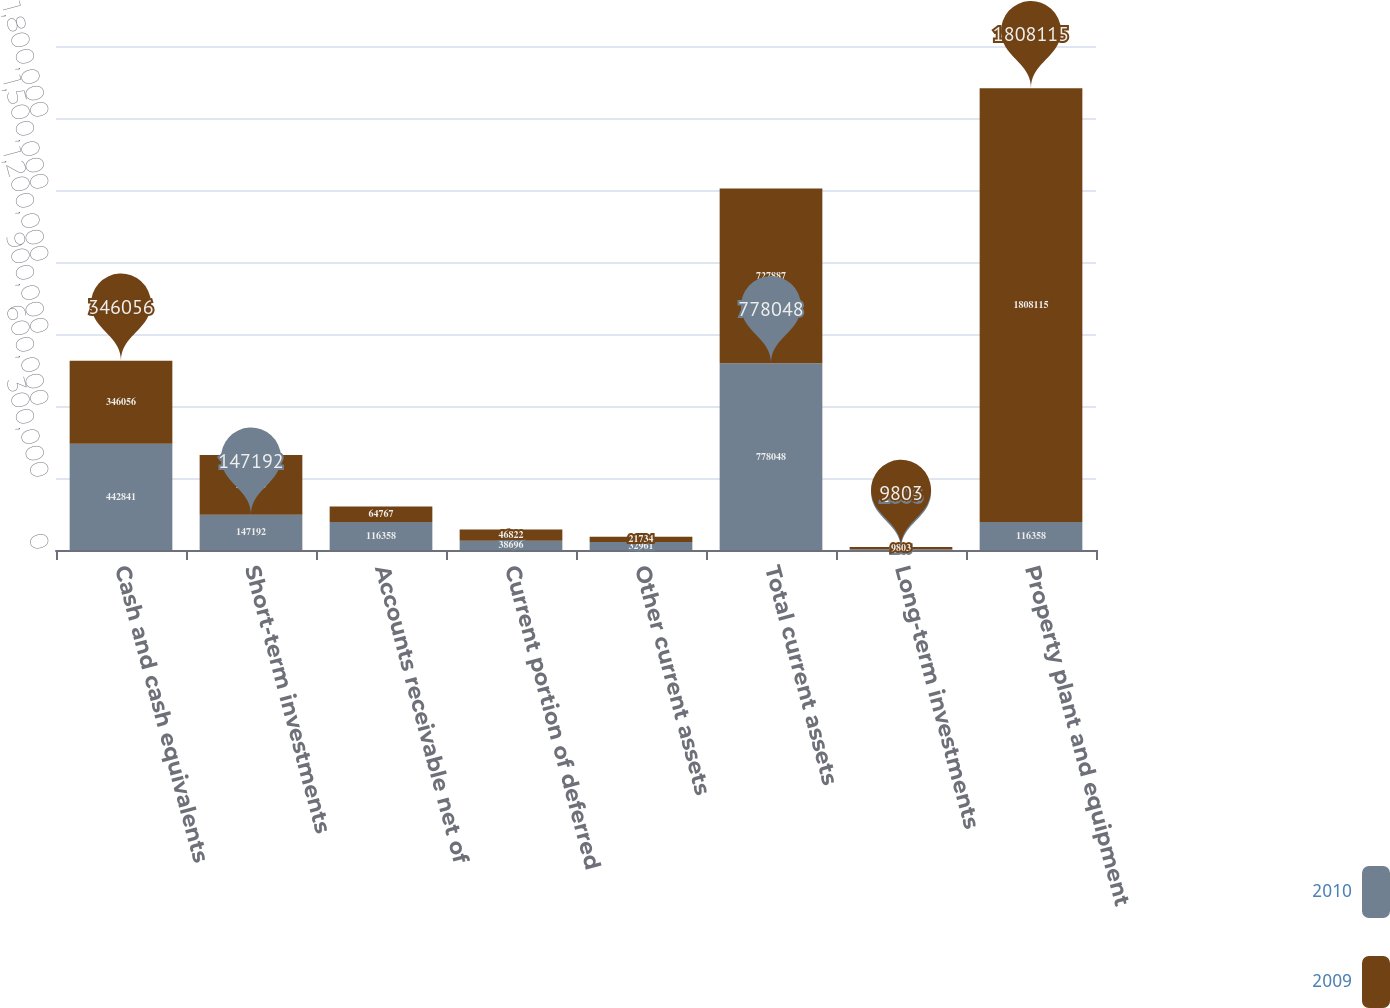Convert chart to OTSL. <chart><loc_0><loc_0><loc_500><loc_500><stacked_bar_chart><ecel><fcel>Cash and cash equivalents<fcel>Short-term investments<fcel>Accounts receivable net of<fcel>Current portion of deferred<fcel>Other current assets<fcel>Total current assets<fcel>Long-term investments<fcel>Property plant and equipment<nl><fcel>2010<fcel>442841<fcel>147192<fcel>116358<fcel>38696<fcel>32961<fcel>778048<fcel>2806<fcel>116358<nl><fcel>2009<fcel>346056<fcel>248508<fcel>64767<fcel>46822<fcel>21734<fcel>727887<fcel>9803<fcel>1.80812e+06<nl></chart> 